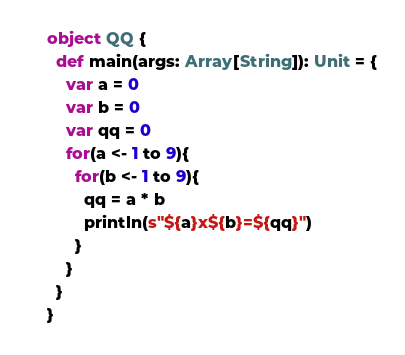<code> <loc_0><loc_0><loc_500><loc_500><_Scala_>object QQ {
  def main(args: Array[String]): Unit = {
    var a = 0
    var b = 0
    var qq = 0
    for(a <- 1 to 9){
      for(b <- 1 to 9){
        qq = a * b
        println(s"${a}x${b}=${qq}")
      }
    }
  }
}</code> 